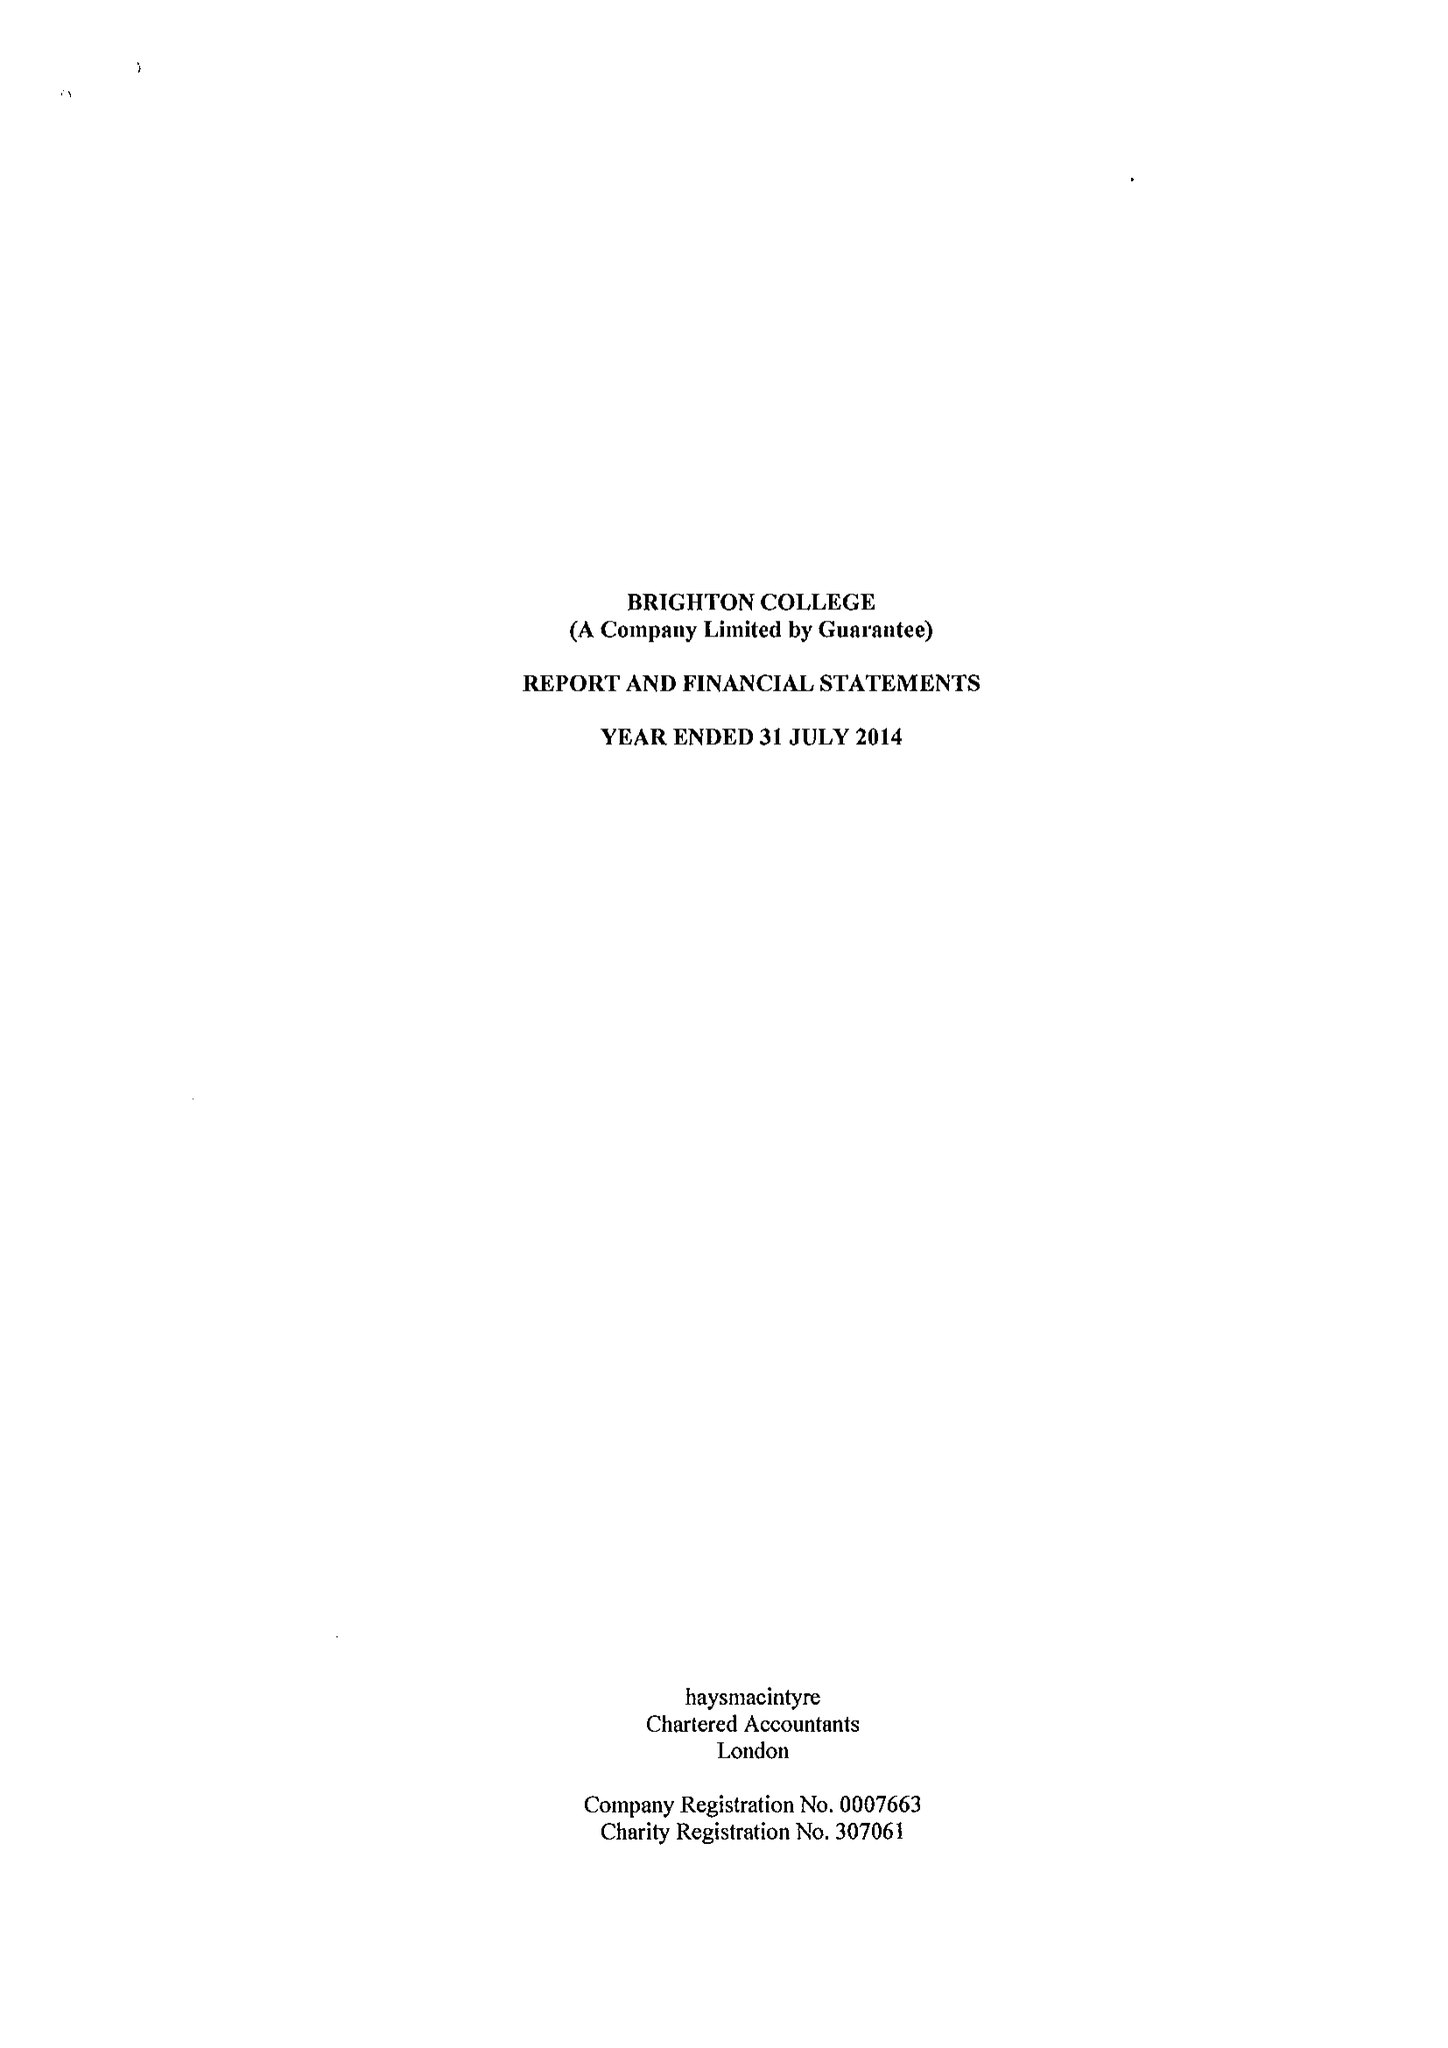What is the value for the charity_number?
Answer the question using a single word or phrase. 307061 